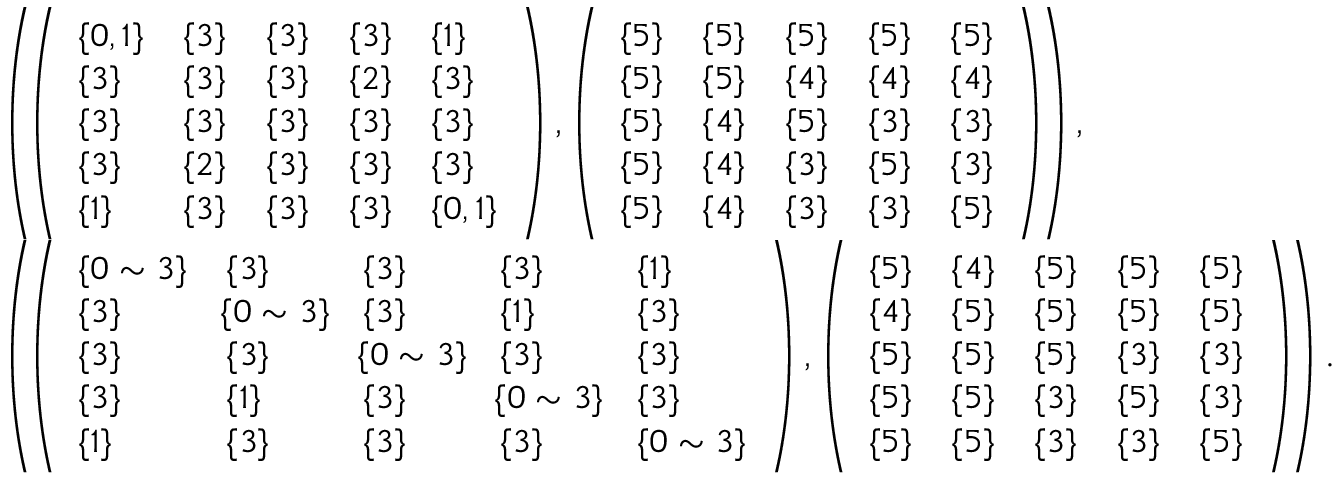<formula> <loc_0><loc_0><loc_500><loc_500>\begin{array} { r l } & { \left ( \, \left ( \begin{array} { l l l l l } { \{ 0 , 1 \} } & { \{ 3 \} } & { \{ 3 \} } & { \{ 3 \} } & { \{ 1 \} } \\ { \{ 3 \} } & { \{ 3 \} } & { \{ 3 \} } & { \{ 2 \} } & { \{ 3 \} } \\ { \{ 3 \} } & { \{ 3 \} } & { \{ 3 \} } & { \{ 3 \} } & { \{ 3 \} } \\ { \{ 3 \} } & { \{ 2 \} } & { \{ 3 \} } & { \{ 3 \} } & { \{ 3 \} } \\ { \{ 1 \} } & { \{ 3 \} } & { \{ 3 \} } & { \{ 3 \} } & { \{ 0 , 1 \} } \end{array} \right ) , \left ( \begin{array} { l l l l l } { \{ 5 \} } & { \{ 5 \} } & { \{ 5 \} } & { \{ 5 \} } & { \{ 5 \} } \\ { \{ 5 \} } & { \{ 5 \} } & { \{ 4 \} } & { \{ 4 \} } & { \{ 4 \} } \\ { \{ 5 \} } & { \{ 4 \} } & { \{ 5 \} } & { \{ 3 \} } & { \{ 3 \} } \\ { \{ 5 \} } & { \{ 4 \} } & { \{ 3 \} } & { \{ 5 \} } & { \{ 3 \} } \\ { \{ 5 \} } & { \{ 4 \} } & { \{ 3 \} } & { \{ 3 \} } & { \{ 5 \} } \end{array} \right ) \, \right ) , } \\ & { \left ( \, \left ( \begin{array} { l l l l l } { \{ 0 \sim 3 \} } & { \{ 3 \} } & { \{ 3 \} } & { \{ 3 \} } & { \{ 1 \} } \\ { \{ 3 \} } & { \, \{ 0 \sim 3 \} \, } & { \{ 3 \} } & { \{ 1 \} } & { \{ 3 \} } \\ { \{ 3 \} } & { \{ 3 \} } & { \, \{ 0 \sim 3 \} \, } & { \{ 3 \} } & { \{ 3 \} } \\ { \{ 3 \} } & { \{ 1 \} } & { \{ 3 \} } & { \, \{ 0 \sim 3 \} \, } & { \{ 3 \} } \\ { \{ 1 \} } & { \{ 3 \} } & { \{ 3 \} } & { \{ 3 \} } & { \{ 0 \sim 3 \} } \end{array} \right ) , \left ( \begin{array} { l l l l l } { \{ 5 \} } & { \{ 4 \} } & { \{ 5 \} } & { \{ 5 \} } & { \{ 5 \} } \\ { \{ 4 \} } & { \{ 5 \} } & { \{ 5 \} } & { \{ 5 \} } & { \{ 5 \} } \\ { \{ 5 \} } & { \{ 5 \} } & { \{ 5 \} } & { \{ 3 \} } & { \{ 3 \} } \\ { \{ 5 \} } & { \{ 5 \} } & { \{ 3 \} } & { \{ 5 \} } & { \{ 3 \} } \\ { \{ 5 \} } & { \{ 5 \} } & { \{ 3 \} } & { \{ 3 \} } & { \{ 5 \} } \end{array} \right ) \, \right ) . } \end{array}</formula> 